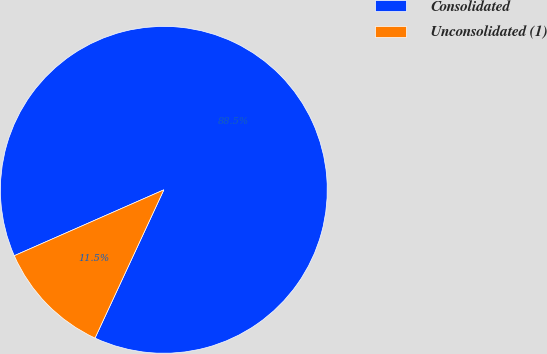Convert chart. <chart><loc_0><loc_0><loc_500><loc_500><pie_chart><fcel>Consolidated<fcel>Unconsolidated (1)<nl><fcel>88.52%<fcel>11.48%<nl></chart> 